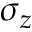<formula> <loc_0><loc_0><loc_500><loc_500>\sigma _ { z }</formula> 